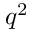Convert formula to latex. <formula><loc_0><loc_0><loc_500><loc_500>q ^ { 2 }</formula> 